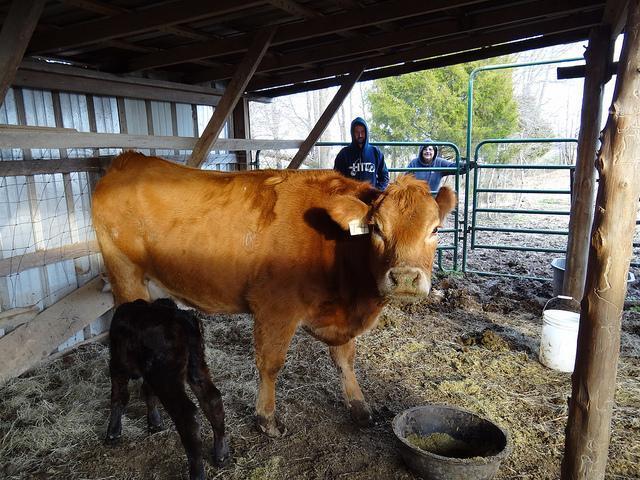How many humans are in the picture?
Give a very brief answer. 2. How many cows are there?
Give a very brief answer. 2. How many carrots do you see?
Give a very brief answer. 0. 